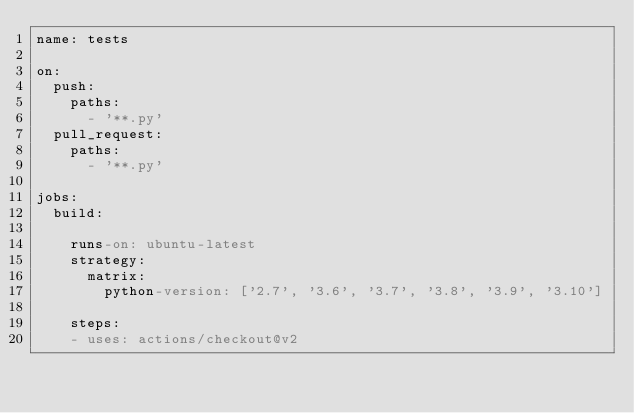Convert code to text. <code><loc_0><loc_0><loc_500><loc_500><_YAML_>name: tests

on:
  push:
    paths:
      - '**.py'
  pull_request:
    paths:
      - '**.py'

jobs:
  build:

    runs-on: ubuntu-latest
    strategy:
      matrix:
        python-version: ['2.7', '3.6', '3.7', '3.8', '3.9', '3.10']

    steps:
    - uses: actions/checkout@v2</code> 